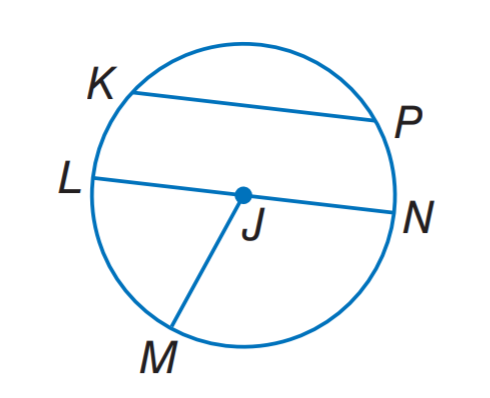Question: If L N = 12.4, what is J M?
Choices:
A. 3.1
B. 6.2
C. 9.3
D. 12.4
Answer with the letter. Answer: B 